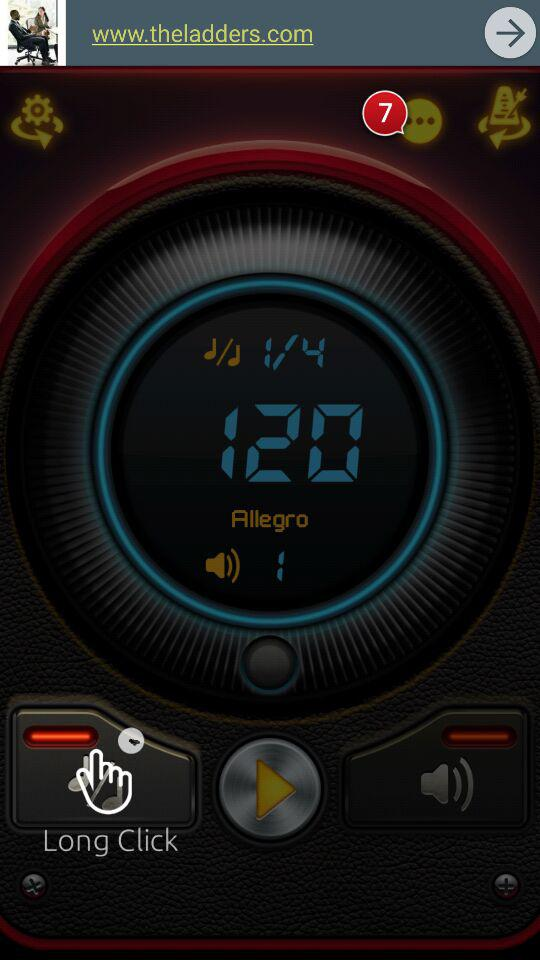How many notifications are there? There are 7 notifications. 